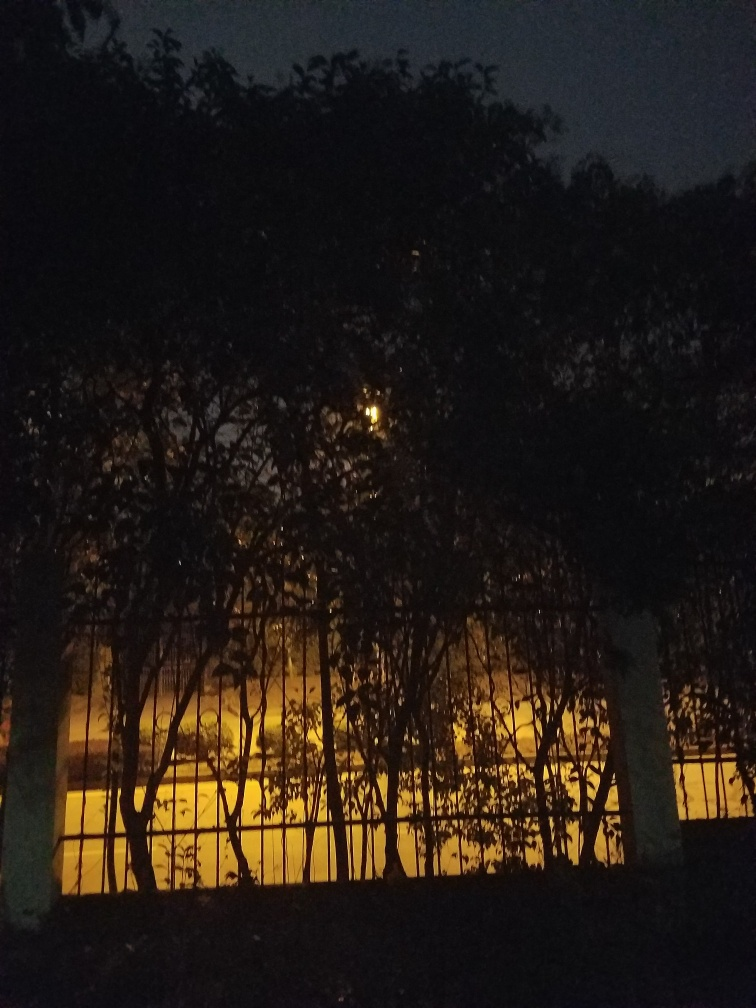What time of day was this image likely taken? This image was likely taken during the evening or at night, as evidenced by the dark sky and the lack of visible sunlight. The artificial light coming from behind the trees suggests it’s after sunset, during what could be called the 'blue hour' or night. 